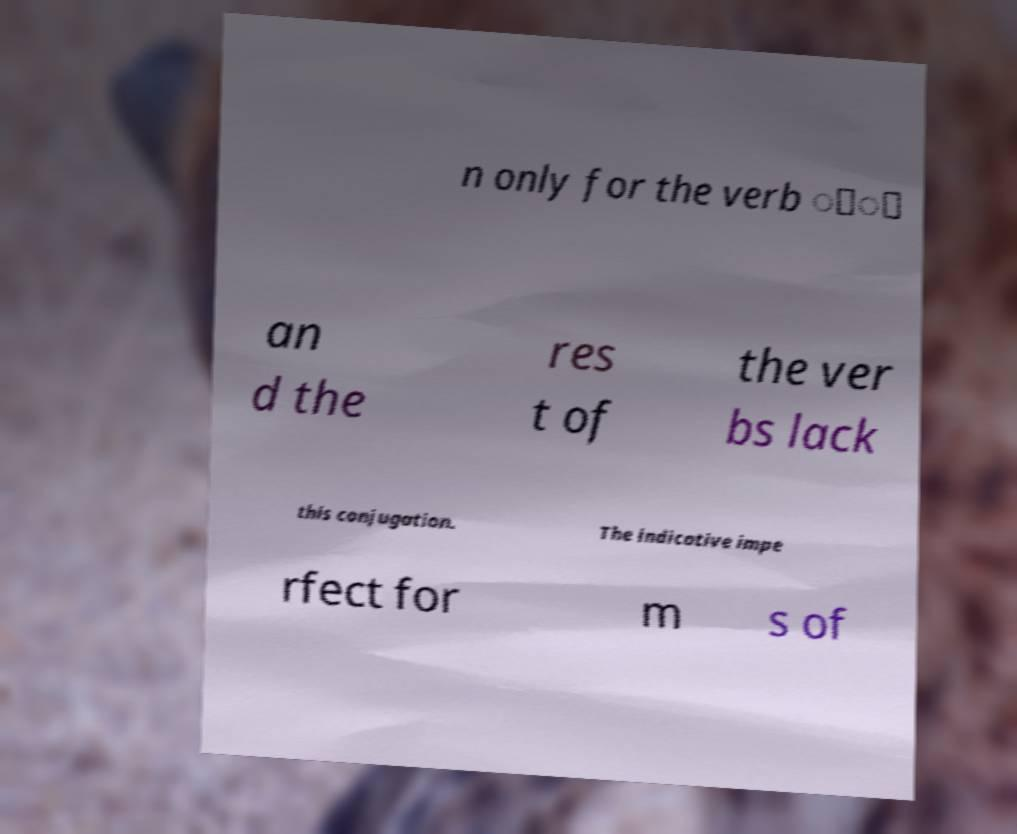Can you accurately transcribe the text from the provided image for me? n only for the verb ोा an d the res t of the ver bs lack this conjugation. The indicative impe rfect for m s of 